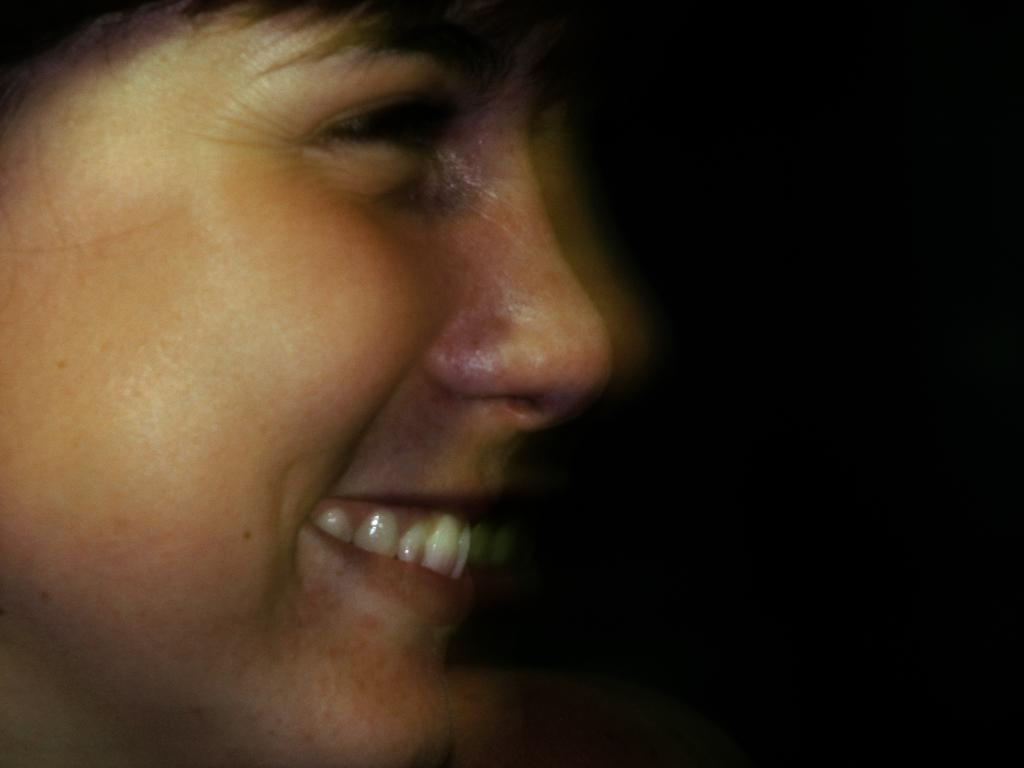What is the main subject of the image? The main subject of the image is a person's face. Can you describe the background of the image? The background of the image is dark. What type of battle is taking place in the image? There is no battle present in the image; it features a person's face against a dark background. How many cushions can be seen in the image? There are no cushions present in the image. 